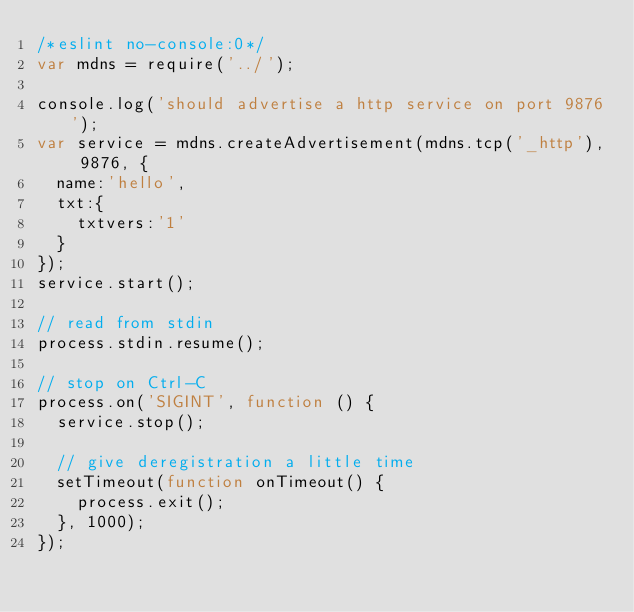<code> <loc_0><loc_0><loc_500><loc_500><_JavaScript_>/*eslint no-console:0*/
var mdns = require('../');

console.log('should advertise a http service on port 9876');
var service = mdns.createAdvertisement(mdns.tcp('_http'), 9876, {
  name:'hello',
  txt:{
    txtvers:'1'
  }
});
service.start();

// read from stdin
process.stdin.resume();

// stop on Ctrl-C
process.on('SIGINT', function () {
  service.stop();

  // give deregistration a little time
  setTimeout(function onTimeout() {
    process.exit();
  }, 1000);
});

</code> 